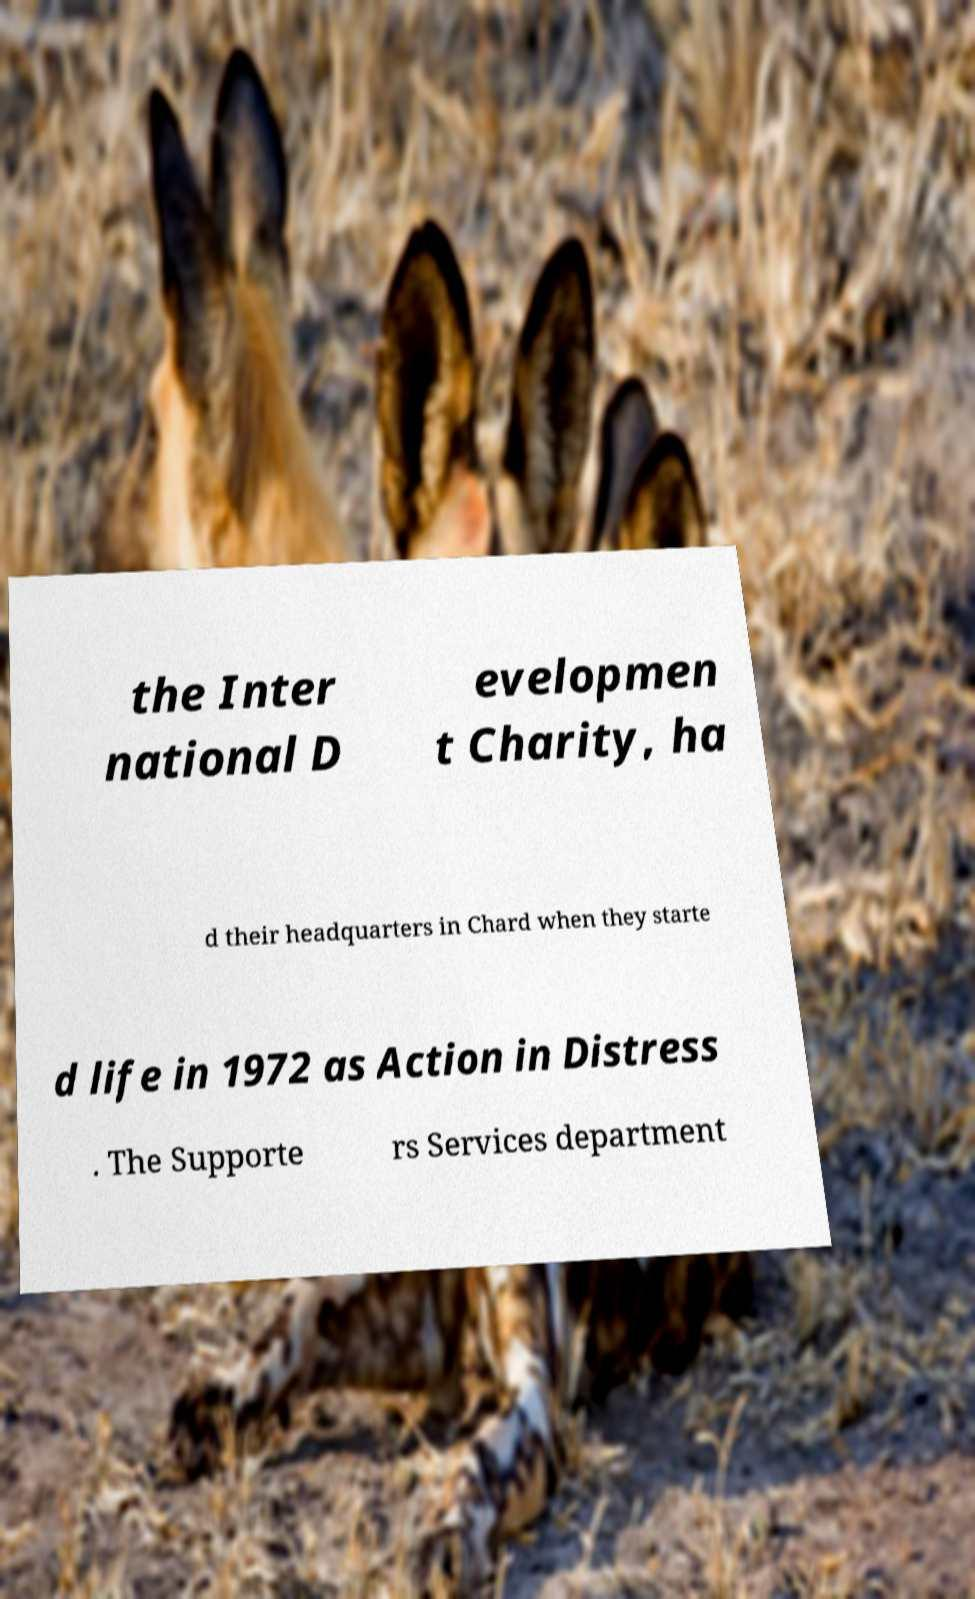Could you assist in decoding the text presented in this image and type it out clearly? the Inter national D evelopmen t Charity, ha d their headquarters in Chard when they starte d life in 1972 as Action in Distress . The Supporte rs Services department 